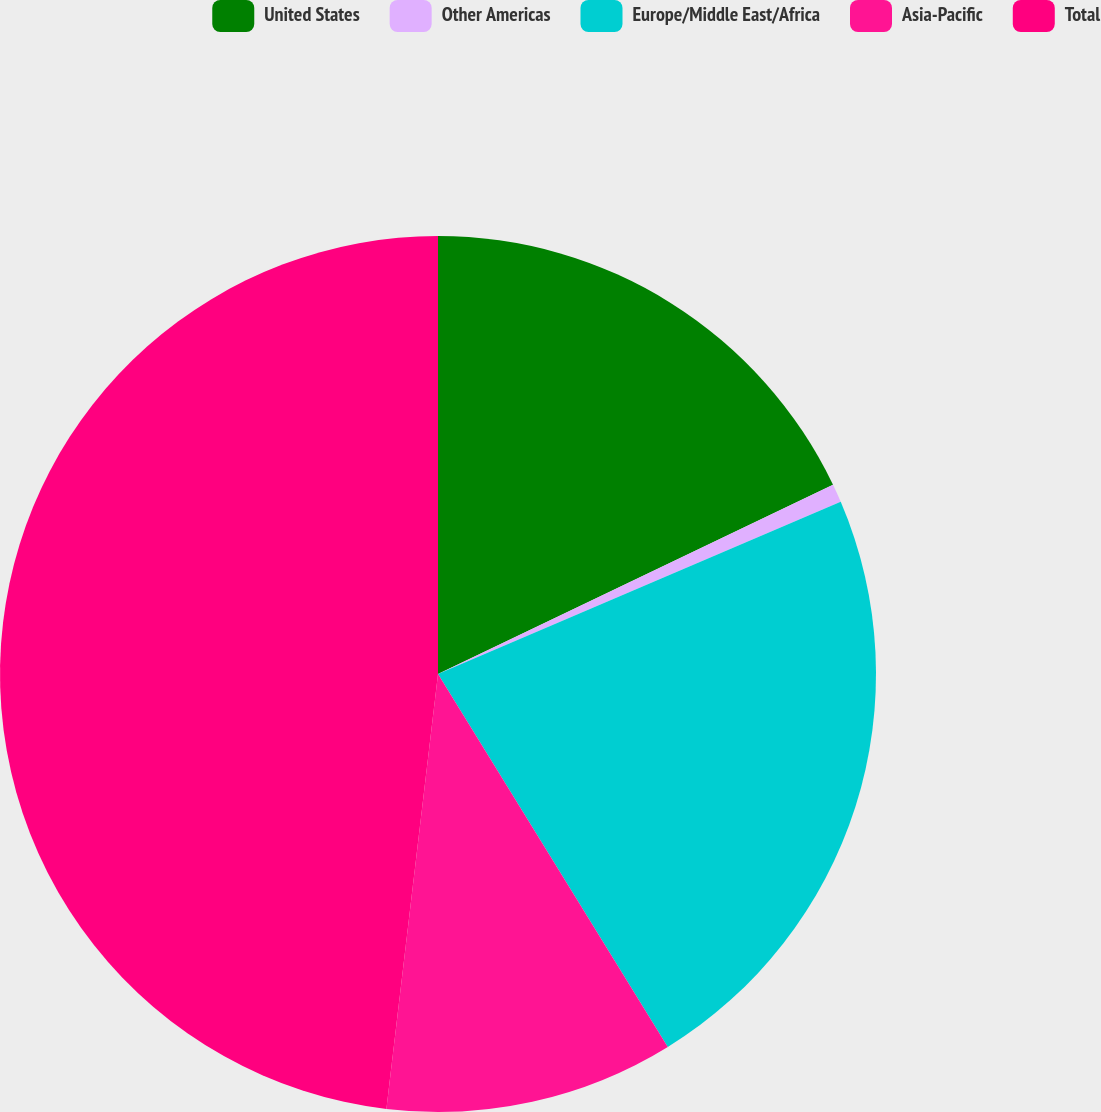<chart> <loc_0><loc_0><loc_500><loc_500><pie_chart><fcel>United States<fcel>Other Americas<fcel>Europe/Middle East/Africa<fcel>Asia-Pacific<fcel>Total<nl><fcel>17.89%<fcel>0.68%<fcel>22.64%<fcel>10.67%<fcel>48.12%<nl></chart> 